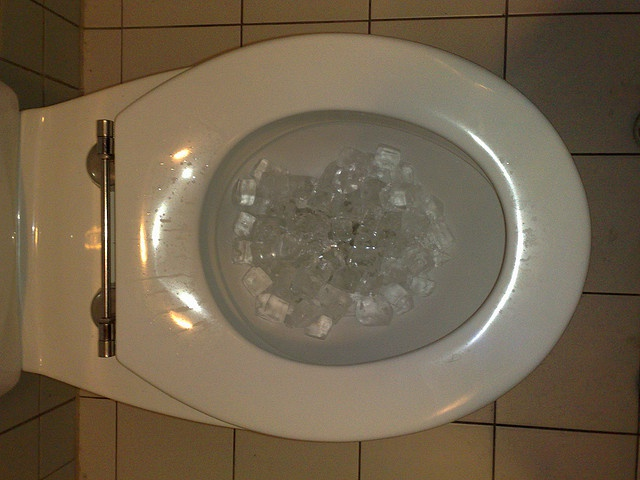Describe the objects in this image and their specific colors. I can see a toilet in maroon, gray, and darkgray tones in this image. 